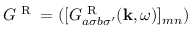Convert formula to latex. <formula><loc_0><loc_0><loc_500><loc_500>G ^ { R } = ( [ G _ { a \sigma b \sigma ^ { \prime } } ^ { R } ( k , \omega ) ] _ { m n } )</formula> 